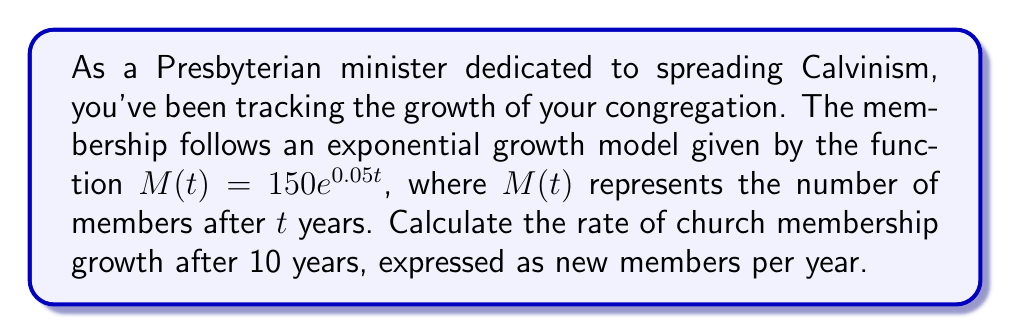Could you help me with this problem? To solve this problem, we need to follow these steps:

1) The rate of growth is given by the derivative of the membership function $M(t)$.

2) First, let's find the derivative of $M(t)$:
   $$\frac{d}{dt}M(t) = \frac{d}{dt}(150e^{0.05t}) = 150 \cdot 0.05e^{0.05t} = 7.5e^{0.05t}$$

3) This derivative $\frac{d}{dt}M(t)$ represents the instantaneous rate of growth at any time $t$.

4) To find the rate after 10 years, we need to evaluate this derivative at $t = 10$:
   $$\frac{d}{dt}M(10) = 7.5e^{0.05(10)} = 7.5e^{0.5} \approx 12.31$$

5) We can verify this by calculating the membership at $t = 10$:
   $$M(10) = 150e^{0.05(10)} = 150e^{0.5} \approx 246.18$$

This means that after 10 years, the congregation will have about 246 members and will be growing at a rate of approximately 12.31 new members per year.
Answer: The rate of church membership growth after 10 years is approximately 12.31 new members per year. 